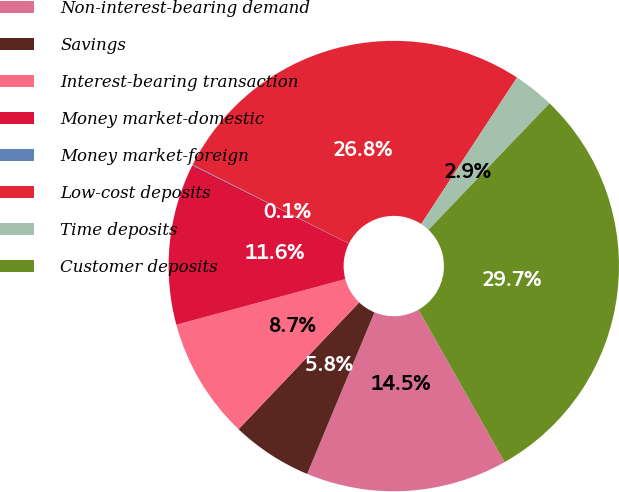Convert chart to OTSL. <chart><loc_0><loc_0><loc_500><loc_500><pie_chart><fcel>Non-interest-bearing demand<fcel>Savings<fcel>Interest-bearing transaction<fcel>Money market-domestic<fcel>Money market-foreign<fcel>Low-cost deposits<fcel>Time deposits<fcel>Customer deposits<nl><fcel>14.47%<fcel>5.82%<fcel>8.7%<fcel>11.58%<fcel>0.05%<fcel>26.78%<fcel>2.94%<fcel>29.66%<nl></chart> 